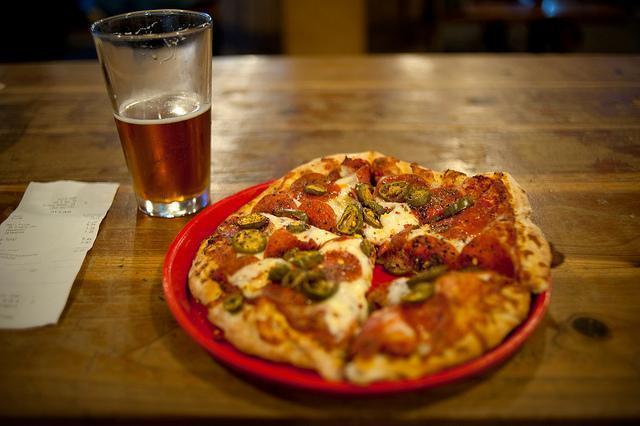What are the green items on top of the pizza?
Answer the question by selecting the correct answer among the 4 following choices and explain your choice with a short sentence. The answer should be formatted with the following format: `Answer: choice
Rationale: rationale.`
Options: Olives, green onions, green peppers, jalapenos. Answer: jalapenos.
Rationale: The green items are spicy peppers. 